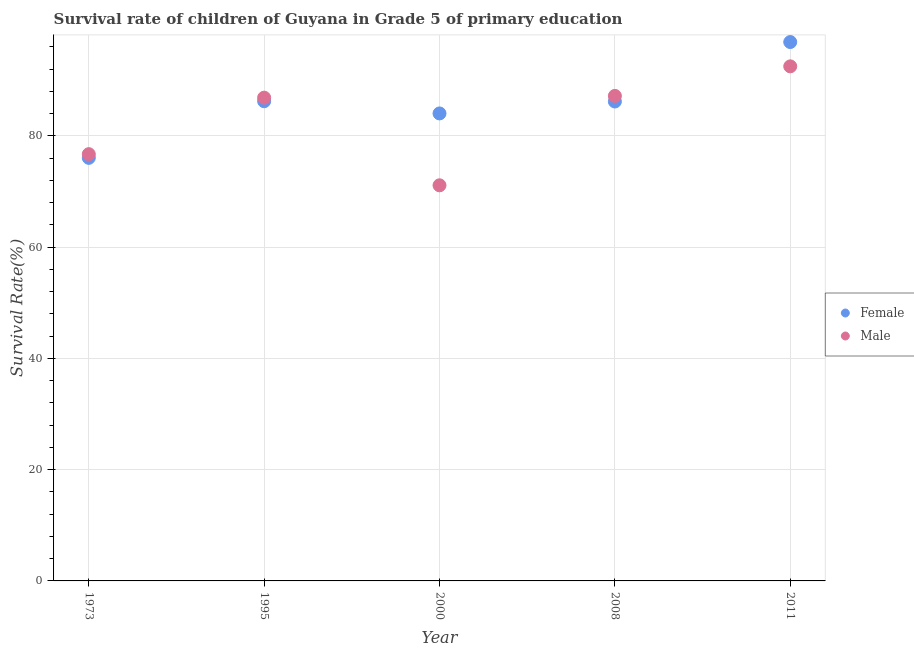How many different coloured dotlines are there?
Provide a short and direct response. 2. Is the number of dotlines equal to the number of legend labels?
Offer a terse response. Yes. What is the survival rate of female students in primary education in 2008?
Offer a very short reply. 86.17. Across all years, what is the maximum survival rate of male students in primary education?
Provide a succinct answer. 92.49. Across all years, what is the minimum survival rate of male students in primary education?
Your response must be concise. 71.1. In which year was the survival rate of male students in primary education maximum?
Provide a short and direct response. 2011. What is the total survival rate of male students in primary education in the graph?
Give a very brief answer. 414.33. What is the difference between the survival rate of female students in primary education in 2000 and that in 2008?
Your answer should be very brief. -2.14. What is the difference between the survival rate of male students in primary education in 1973 and the survival rate of female students in primary education in 2000?
Offer a terse response. -7.32. What is the average survival rate of male students in primary education per year?
Ensure brevity in your answer.  82.87. In the year 1973, what is the difference between the survival rate of female students in primary education and survival rate of male students in primary education?
Your response must be concise. -0.67. What is the ratio of the survival rate of male students in primary education in 1973 to that in 2000?
Offer a terse response. 1.08. Is the difference between the survival rate of male students in primary education in 1973 and 2000 greater than the difference between the survival rate of female students in primary education in 1973 and 2000?
Provide a succinct answer. Yes. What is the difference between the highest and the second highest survival rate of male students in primary education?
Offer a terse response. 5.31. What is the difference between the highest and the lowest survival rate of female students in primary education?
Ensure brevity in your answer.  20.82. Is the sum of the survival rate of male students in primary education in 1973 and 1995 greater than the maximum survival rate of female students in primary education across all years?
Provide a succinct answer. Yes. Is the survival rate of male students in primary education strictly less than the survival rate of female students in primary education over the years?
Provide a short and direct response. No. What is the difference between two consecutive major ticks on the Y-axis?
Offer a very short reply. 20. Are the values on the major ticks of Y-axis written in scientific E-notation?
Make the answer very short. No. Does the graph contain any zero values?
Offer a very short reply. No. How are the legend labels stacked?
Keep it short and to the point. Vertical. What is the title of the graph?
Keep it short and to the point. Survival rate of children of Guyana in Grade 5 of primary education. Does "Methane" appear as one of the legend labels in the graph?
Your response must be concise. No. What is the label or title of the Y-axis?
Your answer should be very brief. Survival Rate(%). What is the Survival Rate(%) in Female in 1973?
Make the answer very short. 76.04. What is the Survival Rate(%) in Male in 1973?
Ensure brevity in your answer.  76.7. What is the Survival Rate(%) of Female in 1995?
Offer a terse response. 86.21. What is the Survival Rate(%) of Male in 1995?
Your response must be concise. 86.86. What is the Survival Rate(%) in Female in 2000?
Keep it short and to the point. 84.02. What is the Survival Rate(%) of Male in 2000?
Offer a terse response. 71.1. What is the Survival Rate(%) of Female in 2008?
Your answer should be compact. 86.17. What is the Survival Rate(%) of Male in 2008?
Provide a succinct answer. 87.17. What is the Survival Rate(%) of Female in 2011?
Ensure brevity in your answer.  96.85. What is the Survival Rate(%) of Male in 2011?
Ensure brevity in your answer.  92.49. Across all years, what is the maximum Survival Rate(%) in Female?
Give a very brief answer. 96.85. Across all years, what is the maximum Survival Rate(%) in Male?
Keep it short and to the point. 92.49. Across all years, what is the minimum Survival Rate(%) in Female?
Your answer should be very brief. 76.04. Across all years, what is the minimum Survival Rate(%) of Male?
Offer a very short reply. 71.1. What is the total Survival Rate(%) in Female in the graph?
Your answer should be compact. 429.3. What is the total Survival Rate(%) in Male in the graph?
Your answer should be very brief. 414.33. What is the difference between the Survival Rate(%) of Female in 1973 and that in 1995?
Make the answer very short. -10.18. What is the difference between the Survival Rate(%) of Male in 1973 and that in 1995?
Keep it short and to the point. -10.16. What is the difference between the Survival Rate(%) in Female in 1973 and that in 2000?
Give a very brief answer. -7.99. What is the difference between the Survival Rate(%) of Male in 1973 and that in 2000?
Give a very brief answer. 5.6. What is the difference between the Survival Rate(%) of Female in 1973 and that in 2008?
Your answer should be compact. -10.13. What is the difference between the Survival Rate(%) in Male in 1973 and that in 2008?
Give a very brief answer. -10.47. What is the difference between the Survival Rate(%) of Female in 1973 and that in 2011?
Offer a very short reply. -20.82. What is the difference between the Survival Rate(%) of Male in 1973 and that in 2011?
Offer a very short reply. -15.78. What is the difference between the Survival Rate(%) in Female in 1995 and that in 2000?
Your response must be concise. 2.19. What is the difference between the Survival Rate(%) in Male in 1995 and that in 2000?
Ensure brevity in your answer.  15.76. What is the difference between the Survival Rate(%) in Female in 1995 and that in 2008?
Your answer should be very brief. 0.05. What is the difference between the Survival Rate(%) of Male in 1995 and that in 2008?
Your answer should be very brief. -0.31. What is the difference between the Survival Rate(%) of Female in 1995 and that in 2011?
Offer a very short reply. -10.64. What is the difference between the Survival Rate(%) in Male in 1995 and that in 2011?
Ensure brevity in your answer.  -5.62. What is the difference between the Survival Rate(%) of Female in 2000 and that in 2008?
Ensure brevity in your answer.  -2.14. What is the difference between the Survival Rate(%) of Male in 2000 and that in 2008?
Your response must be concise. -16.07. What is the difference between the Survival Rate(%) of Female in 2000 and that in 2011?
Provide a short and direct response. -12.83. What is the difference between the Survival Rate(%) of Male in 2000 and that in 2011?
Keep it short and to the point. -21.38. What is the difference between the Survival Rate(%) of Female in 2008 and that in 2011?
Your answer should be very brief. -10.69. What is the difference between the Survival Rate(%) of Male in 2008 and that in 2011?
Make the answer very short. -5.31. What is the difference between the Survival Rate(%) in Female in 1973 and the Survival Rate(%) in Male in 1995?
Provide a succinct answer. -10.82. What is the difference between the Survival Rate(%) in Female in 1973 and the Survival Rate(%) in Male in 2000?
Your response must be concise. 4.93. What is the difference between the Survival Rate(%) of Female in 1973 and the Survival Rate(%) of Male in 2008?
Provide a short and direct response. -11.14. What is the difference between the Survival Rate(%) in Female in 1973 and the Survival Rate(%) in Male in 2011?
Keep it short and to the point. -16.45. What is the difference between the Survival Rate(%) of Female in 1995 and the Survival Rate(%) of Male in 2000?
Offer a very short reply. 15.11. What is the difference between the Survival Rate(%) of Female in 1995 and the Survival Rate(%) of Male in 2008?
Ensure brevity in your answer.  -0.96. What is the difference between the Survival Rate(%) in Female in 1995 and the Survival Rate(%) in Male in 2011?
Offer a very short reply. -6.27. What is the difference between the Survival Rate(%) in Female in 2000 and the Survival Rate(%) in Male in 2008?
Keep it short and to the point. -3.15. What is the difference between the Survival Rate(%) of Female in 2000 and the Survival Rate(%) of Male in 2011?
Give a very brief answer. -8.46. What is the difference between the Survival Rate(%) in Female in 2008 and the Survival Rate(%) in Male in 2011?
Make the answer very short. -6.32. What is the average Survival Rate(%) of Female per year?
Provide a succinct answer. 85.86. What is the average Survival Rate(%) of Male per year?
Keep it short and to the point. 82.87. In the year 1973, what is the difference between the Survival Rate(%) of Female and Survival Rate(%) of Male?
Keep it short and to the point. -0.67. In the year 1995, what is the difference between the Survival Rate(%) of Female and Survival Rate(%) of Male?
Your response must be concise. -0.65. In the year 2000, what is the difference between the Survival Rate(%) of Female and Survival Rate(%) of Male?
Your answer should be compact. 12.92. In the year 2008, what is the difference between the Survival Rate(%) in Female and Survival Rate(%) in Male?
Make the answer very short. -1.01. In the year 2011, what is the difference between the Survival Rate(%) in Female and Survival Rate(%) in Male?
Your response must be concise. 4.37. What is the ratio of the Survival Rate(%) of Female in 1973 to that in 1995?
Offer a very short reply. 0.88. What is the ratio of the Survival Rate(%) in Male in 1973 to that in 1995?
Offer a very short reply. 0.88. What is the ratio of the Survival Rate(%) in Female in 1973 to that in 2000?
Your answer should be very brief. 0.91. What is the ratio of the Survival Rate(%) of Male in 1973 to that in 2000?
Give a very brief answer. 1.08. What is the ratio of the Survival Rate(%) in Female in 1973 to that in 2008?
Offer a terse response. 0.88. What is the ratio of the Survival Rate(%) in Male in 1973 to that in 2008?
Keep it short and to the point. 0.88. What is the ratio of the Survival Rate(%) of Female in 1973 to that in 2011?
Give a very brief answer. 0.79. What is the ratio of the Survival Rate(%) in Male in 1973 to that in 2011?
Provide a succinct answer. 0.83. What is the ratio of the Survival Rate(%) of Female in 1995 to that in 2000?
Your answer should be compact. 1.03. What is the ratio of the Survival Rate(%) of Male in 1995 to that in 2000?
Keep it short and to the point. 1.22. What is the ratio of the Survival Rate(%) in Male in 1995 to that in 2008?
Offer a very short reply. 1. What is the ratio of the Survival Rate(%) of Female in 1995 to that in 2011?
Offer a very short reply. 0.89. What is the ratio of the Survival Rate(%) of Male in 1995 to that in 2011?
Provide a succinct answer. 0.94. What is the ratio of the Survival Rate(%) of Female in 2000 to that in 2008?
Make the answer very short. 0.98. What is the ratio of the Survival Rate(%) in Male in 2000 to that in 2008?
Your answer should be compact. 0.82. What is the ratio of the Survival Rate(%) of Female in 2000 to that in 2011?
Your response must be concise. 0.87. What is the ratio of the Survival Rate(%) of Male in 2000 to that in 2011?
Your response must be concise. 0.77. What is the ratio of the Survival Rate(%) of Female in 2008 to that in 2011?
Offer a very short reply. 0.89. What is the ratio of the Survival Rate(%) in Male in 2008 to that in 2011?
Provide a succinct answer. 0.94. What is the difference between the highest and the second highest Survival Rate(%) of Female?
Your response must be concise. 10.64. What is the difference between the highest and the second highest Survival Rate(%) in Male?
Provide a succinct answer. 5.31. What is the difference between the highest and the lowest Survival Rate(%) of Female?
Provide a succinct answer. 20.82. What is the difference between the highest and the lowest Survival Rate(%) in Male?
Provide a succinct answer. 21.38. 